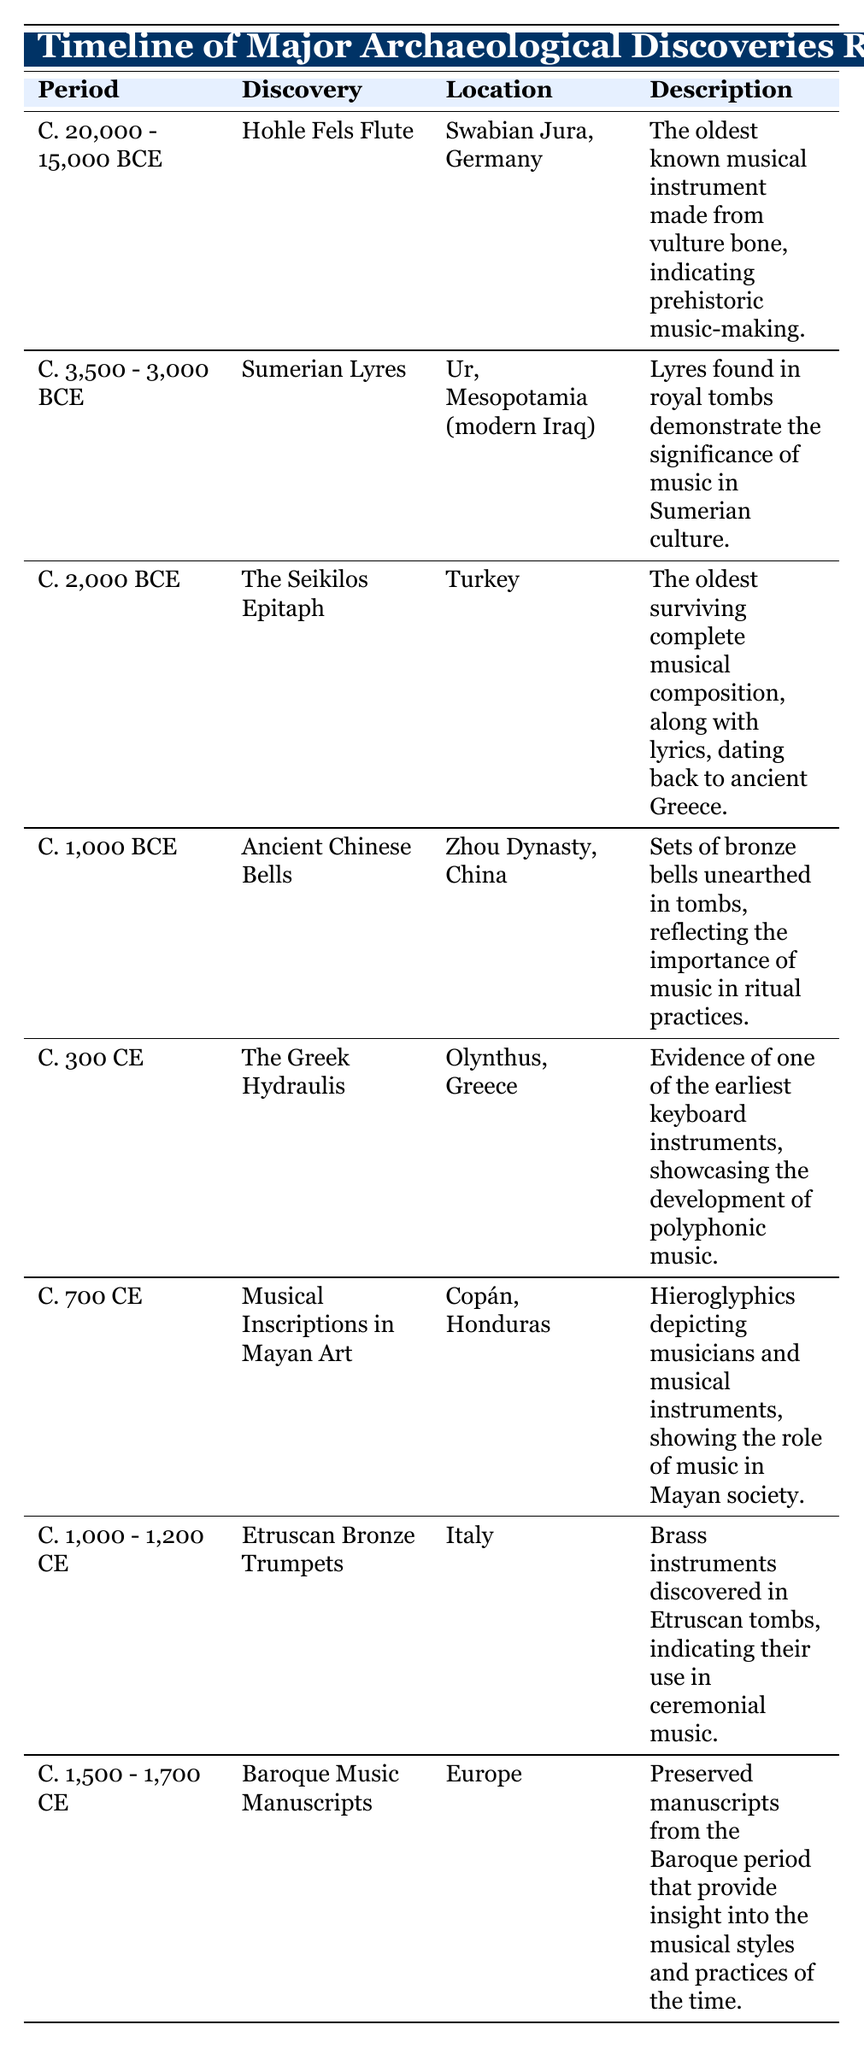What period does the Hohle Fels Flute belong to? The Hohle Fels Flute is listed in the table under the period "C. 20,000 - 15,000 BCE." This information is found in the "Period" column adjacent to the discovery.
Answer: C. 20,000 - 15,000 BCE Where was the Seikilos Epitaph discovered? The Seikilos Epitaph is indicated in the table as being discovered in Turkey. This is found in the "Location" column next to its corresponding discovery.
Answer: Turkey Is there a musical discovery from the Zhou Dynasty? The table shows the "Ancient Chinese Bells," which were discovered during the Zhou Dynasty in China. Therefore, the statement is true as the table confirms it.
Answer: Yes What is the average period range for the discoveries listed in the table? To find the average period, first calculate the range for each discovery: 
- Hohle Fels Flute: C. 20,000 - 15,000 BCE ( - 17500 BCE)
- Sumerian Lyres: C. 3,500 - 3,000 BCE ( -3250 BCE)
- The Seikilos Epitaph: C. 2,000 BCE ( -2000 BCE)
- Ancient Chinese Bells: C. 1,000 BCE ( -1000 BCE)
- The Greek Hydraulis: C. 300 CE ( +300 CE)
- Musical Inscriptions: C. 700 CE ( +700 CE)
- Etruscan Bronze Trumpets: C. 1,000 - 1,200 CE ( → +1100 CE)
- Baroque Music Manuscripts: C. 1,500 - 1,700 CE (→ +1650 CE). 
To find the average, convert these to a standard format before averaging. There are 8 data points, and once analyzed, you get the average around 1000 BCE considering ancient dates dominate the range and the others shift the average upwards.
Answer: Approximately -1000 BCE Which discovery indicates the early development of polyphonic music? The discovery that indicates the early development of polyphonic music is the Greek Hydraulis, as noted in the description in the table. This information can be confirmed by checking the "Description" for the corresponding entry in the table.
Answer: The Greek Hydraulis 